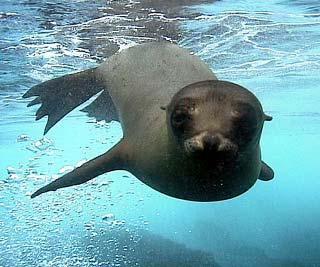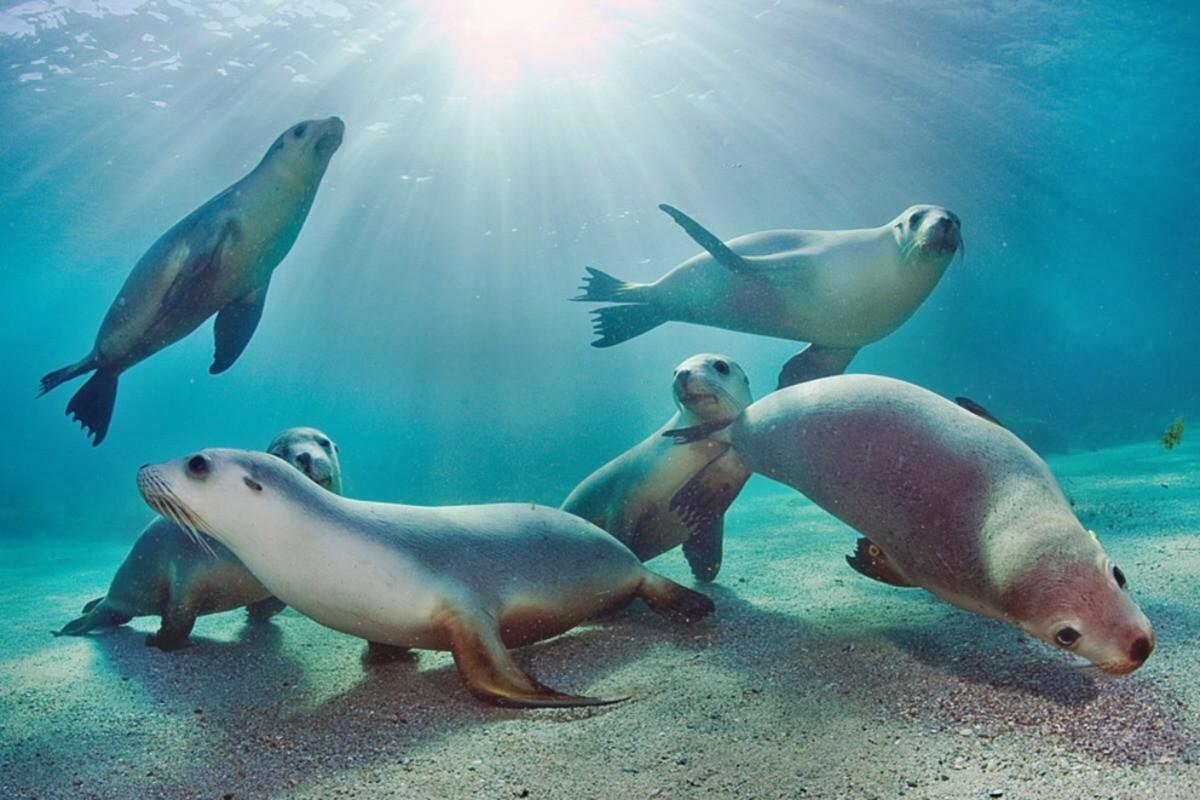The first image is the image on the left, the second image is the image on the right. Given the left and right images, does the statement "A total of two seals are shown, all of them swimming underwater, and one seal is swimming forward and eyeing the camera." hold true? Answer yes or no. No. 